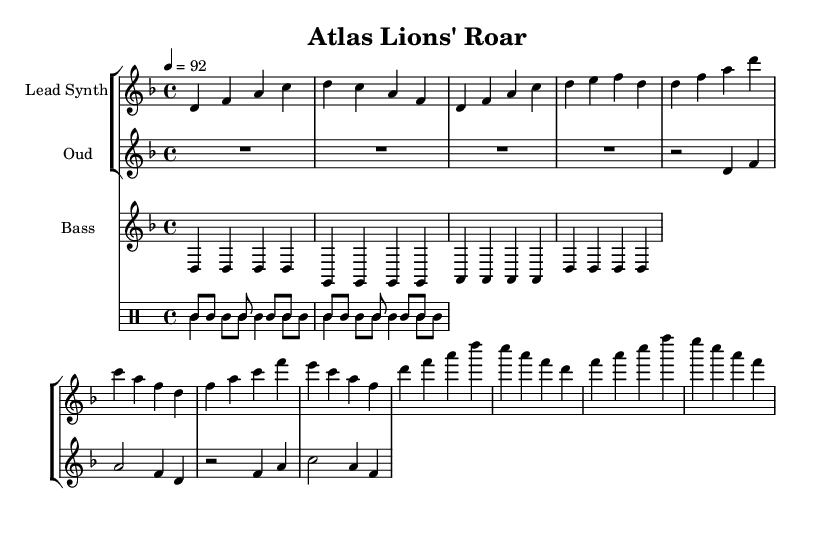What is the time signature of this music? The time signature appears at the beginning of the score and indicates that there are four beats per measure and that each quarter note gets one beat. This is expressed as 4/4.
Answer: 4/4 What is the tempo marking for this piece? The tempo marking, located near the beginning of the score, specifies how fast the piece should be played. It indicates a tempo of 92 beats per minute.
Answer: 92 How many instruments are featured in this score? By counting the different staves in the score, I note that there are three distinct instruments (Lead Synth, Oud, and Bass) listed, along with a drum section consisting of two patterns.
Answer: 3 What is the key signature of the music? The key signature is indicated by the absence of sharps or flats in the staff, which places this piece in D minor. This can be verified as it uses notes primarily associated with this key.
Answer: D minor What rhythmic pattern is used for the darbuka? The rhythmic pattern for the darbuka is shown in the drum section and consists of a repeated sequence of bass drum (bd) notes and rests, described with specific notations. Counting these elements reveals a consistent pattern.
Answer: bd8 bd s bd s bd bd s How is the structure of the music organized, particularly in the verse? The structure can be understood by examining the repeated sections and their respective rhythms and note patterns. The verse exhibits a specific sequence of notes and rests defined in the lead synth and oud parts. The repetition signifies a typical verse arrangement found in hip-hop.
Answer: Verse has a distinct sequence What role does the oud play in this piece? The oud serves as a melodic instrument, providing harmonic support and a cultural flair typical of Moroccan music, layered with the rhythmic components from the drums and bass. Its patterns are specifically designed to complement the lead synth.
Answer: Melodic support 